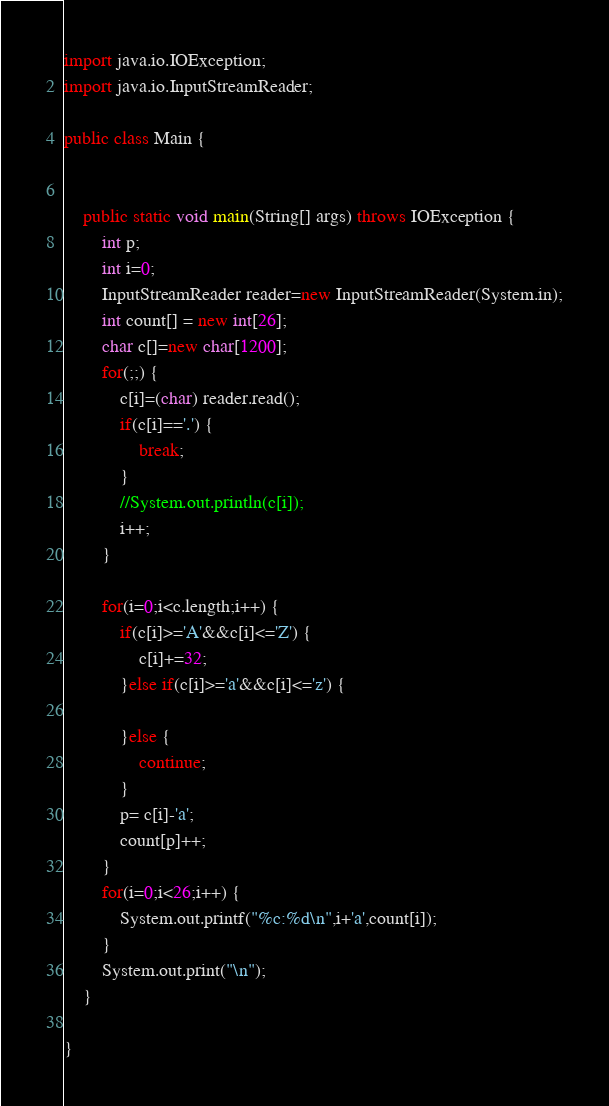Convert code to text. <code><loc_0><loc_0><loc_500><loc_500><_Java_>import java.io.IOException;
import java.io.InputStreamReader;

public class Main {
	
	
	public static void main(String[] args) throws IOException {
		int p;
		int i=0;
   	    InputStreamReader reader=new InputStreamReader(System.in);
		int count[] = new int[26];
		char c[]=new char[1200];
		for(;;) {
			c[i]=(char) reader.read();
			if(c[i]=='.') {
				break;
			}
	        //System.out.println(c[i]);
			i++;
		}
	    
		for(i=0;i<c.length;i++) {
			if(c[i]>='A'&&c[i]<='Z') {
				c[i]+=32;
			}else if(c[i]>='a'&&c[i]<='z') {
				
			}else {
				continue;
			}
			p= c[i]-'a';
			count[p]++;
		}
		for(i=0;i<26;i++) {
			System.out.printf("%c:%d\n",i+'a',count[i]);
		}
		System.out.print("\n");	
	}
	
}
</code> 